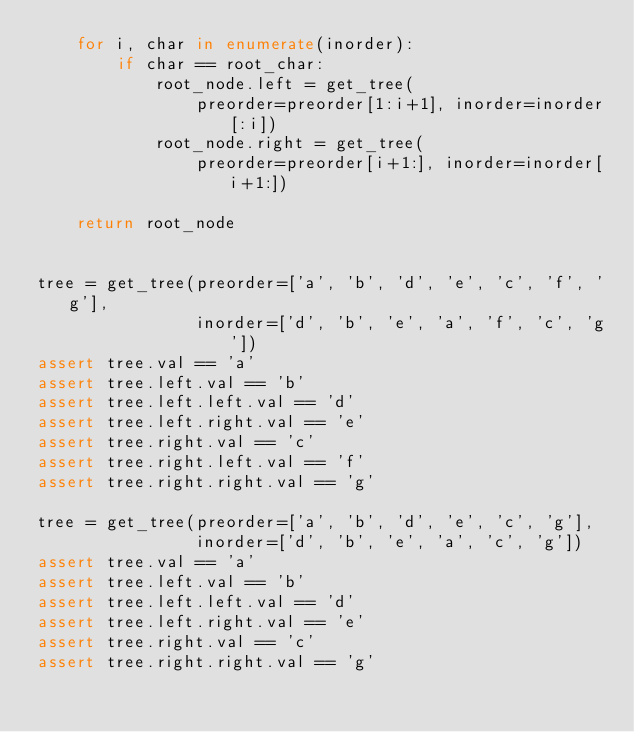Convert code to text. <code><loc_0><loc_0><loc_500><loc_500><_Python_>    for i, char in enumerate(inorder):
        if char == root_char:
            root_node.left = get_tree(
                preorder=preorder[1:i+1], inorder=inorder[:i])
            root_node.right = get_tree(
                preorder=preorder[i+1:], inorder=inorder[i+1:])

    return root_node


tree = get_tree(preorder=['a', 'b', 'd', 'e', 'c', 'f', 'g'],
                inorder=['d', 'b', 'e', 'a', 'f', 'c', 'g'])
assert tree.val == 'a'
assert tree.left.val == 'b'
assert tree.left.left.val == 'd'
assert tree.left.right.val == 'e'
assert tree.right.val == 'c'
assert tree.right.left.val == 'f'
assert tree.right.right.val == 'g'

tree = get_tree(preorder=['a', 'b', 'd', 'e', 'c', 'g'],
                inorder=['d', 'b', 'e', 'a', 'c', 'g'])
assert tree.val == 'a'
assert tree.left.val == 'b'
assert tree.left.left.val == 'd'
assert tree.left.right.val == 'e'
assert tree.right.val == 'c'
assert tree.right.right.val == 'g'
</code> 